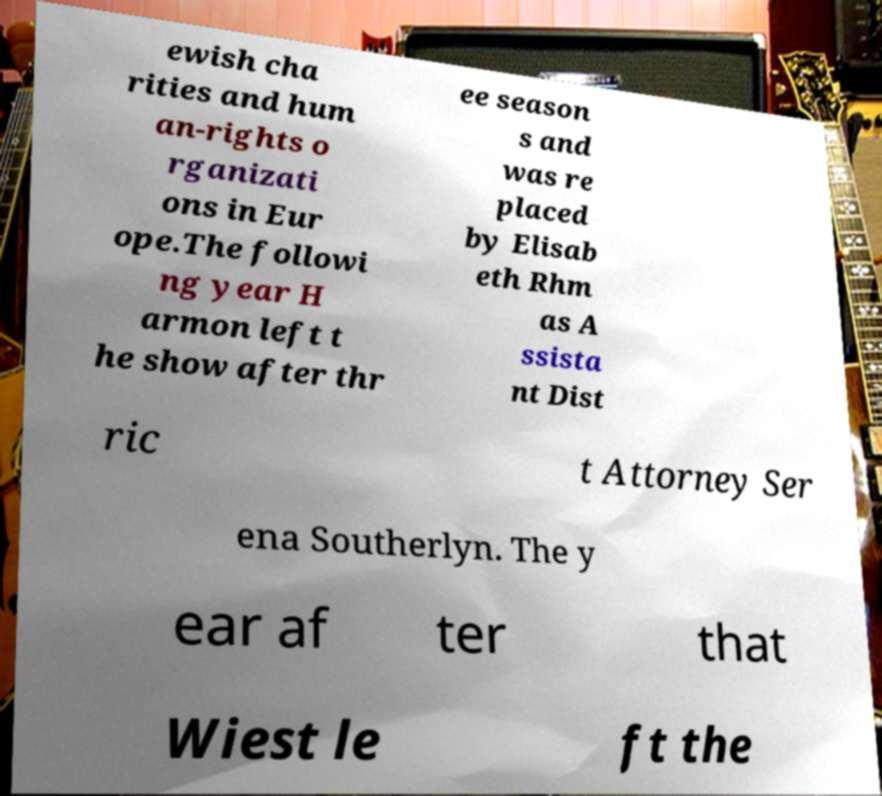What messages or text are displayed in this image? I need them in a readable, typed format. ewish cha rities and hum an-rights o rganizati ons in Eur ope.The followi ng year H armon left t he show after thr ee season s and was re placed by Elisab eth Rhm as A ssista nt Dist ric t Attorney Ser ena Southerlyn. The y ear af ter that Wiest le ft the 